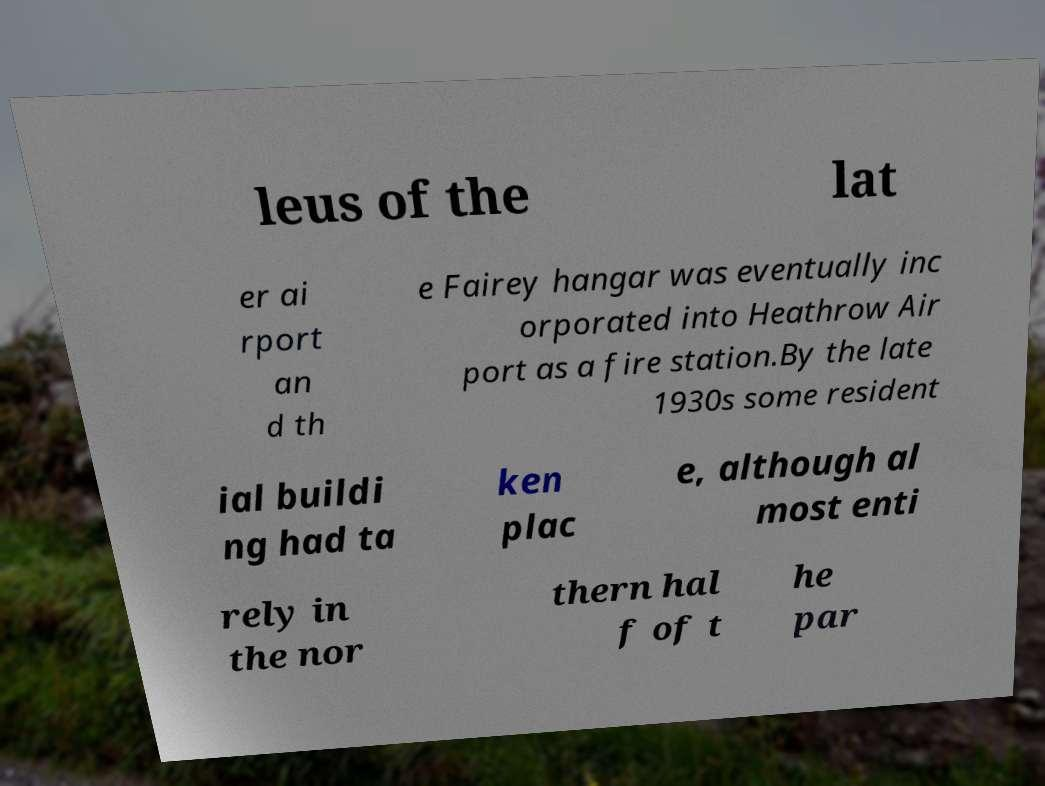There's text embedded in this image that I need extracted. Can you transcribe it verbatim? leus of the lat er ai rport an d th e Fairey hangar was eventually inc orporated into Heathrow Air port as a fire station.By the late 1930s some resident ial buildi ng had ta ken plac e, although al most enti rely in the nor thern hal f of t he par 